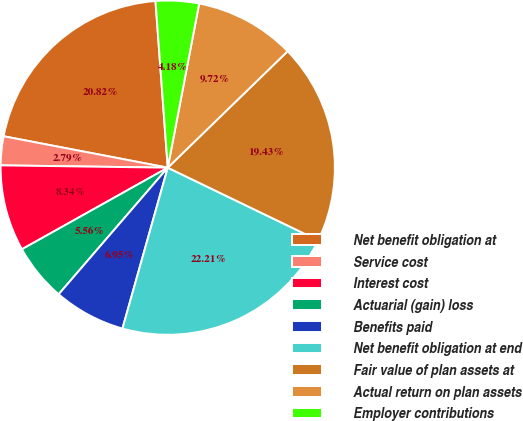Convert chart. <chart><loc_0><loc_0><loc_500><loc_500><pie_chart><fcel>Net benefit obligation at<fcel>Service cost<fcel>Interest cost<fcel>Actuarial (gain) loss<fcel>Benefits paid<fcel>Net benefit obligation at end<fcel>Fair value of plan assets at<fcel>Actual return on plan assets<fcel>Employer contributions<nl><fcel>20.82%<fcel>2.79%<fcel>8.34%<fcel>5.56%<fcel>6.95%<fcel>22.21%<fcel>19.43%<fcel>9.72%<fcel>4.18%<nl></chart> 